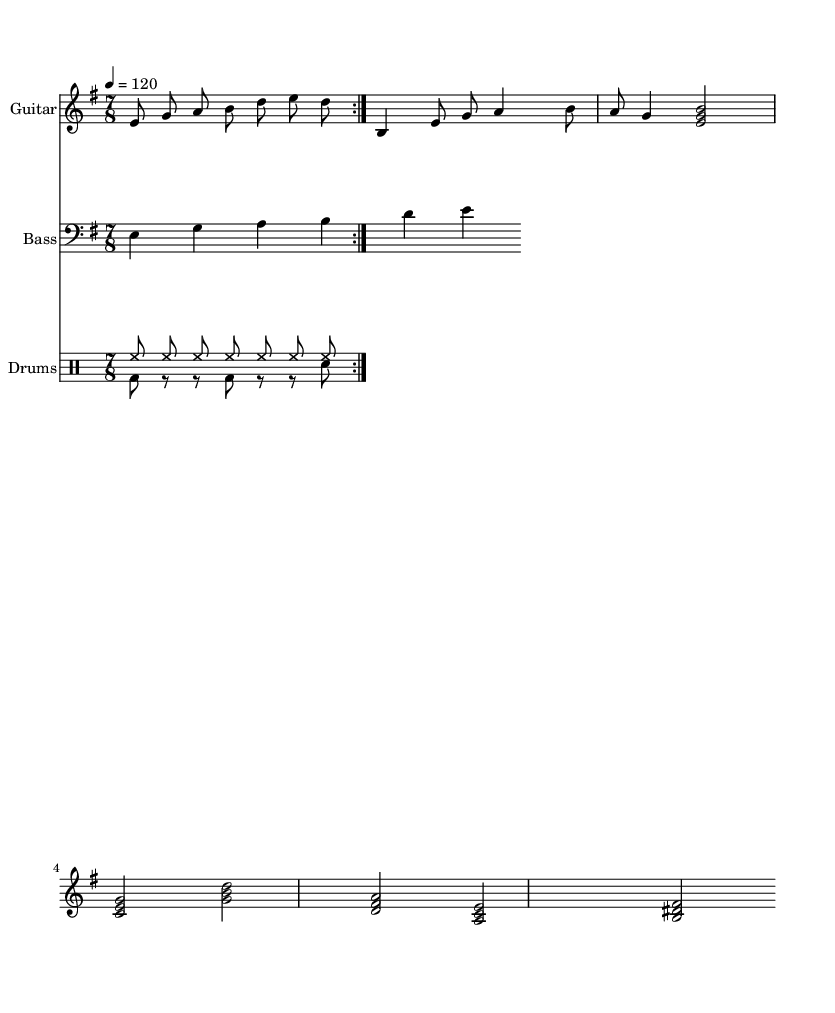What is the key signature of this music? The key signature is E minor, which has one sharp (F#). We can determine this by looking at the key signature indicated at the beginning of the score.
Answer: E minor What is the time signature of this music? The time signature is 7/8, which is displayed next to the key signature at the start of the piece. It indicates that there are seven eighth notes per measure.
Answer: 7/8 What is the tempo marking for this piece? The tempo marking states "4 = 120," meaning there are 120 beats per minute, and each quarter note gets one beat. This is typically found at the beginning of the score under tempo indications.
Answer: 120 How many measures does the guitar riff repeat? The guitar riff repeats twice, as indicated by the "repeat volta" notation that indicates the section should loop before continuing.
Answer: 2 What type of drum pattern is predominantly used in this sheet music? The drum pattern listed as "hihat8 hihat hihat..." implies an alternating high hat pattern, which is typical in metal music, and it gives a consistent rhythm under the guitar and bass lines.
Answer: Hihat What emotional theme is expressed through the musical structure? The combination of minor key, shifting rhythms, and dynamic contrasts suggests a theme of introspection or empathy, reflecting the progressive metal style that often explores complex emotional landscapes.
Answer: Empathy 